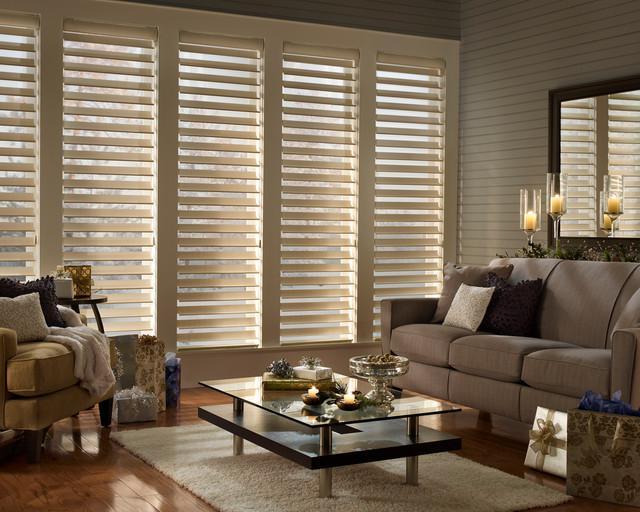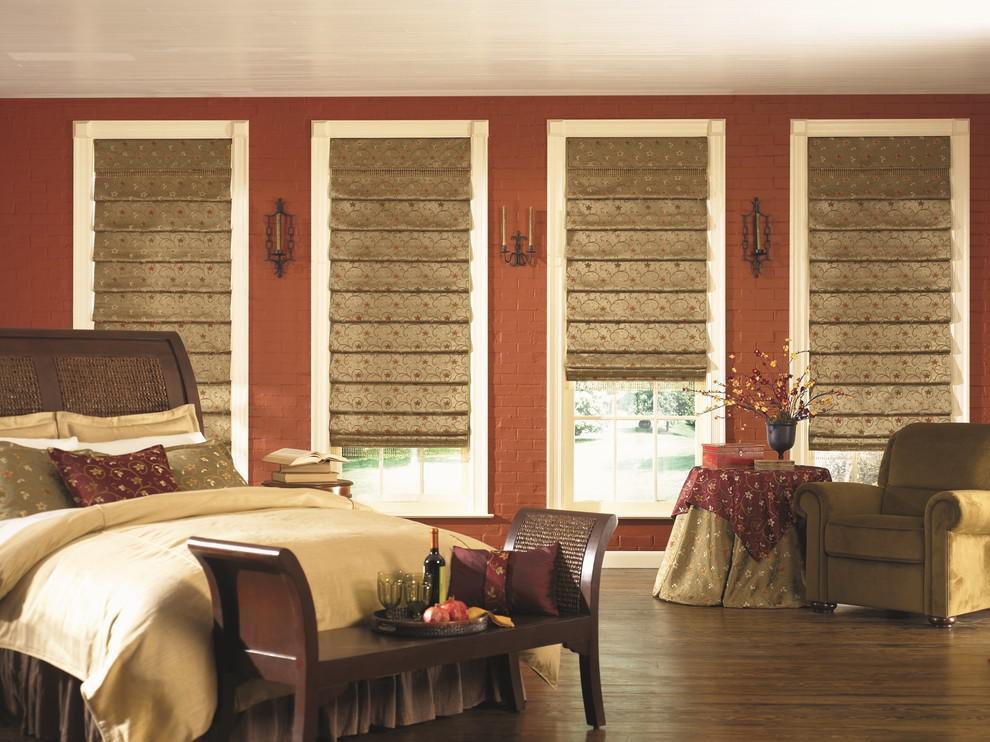The first image is the image on the left, the second image is the image on the right. Examine the images to the left and right. Is the description "There is a total of seven shades." accurate? Answer yes or no. No. The first image is the image on the left, the second image is the image on the right. Assess this claim about the two images: "A window blind is partially pulled up in both images.". Correct or not? Answer yes or no. No. 